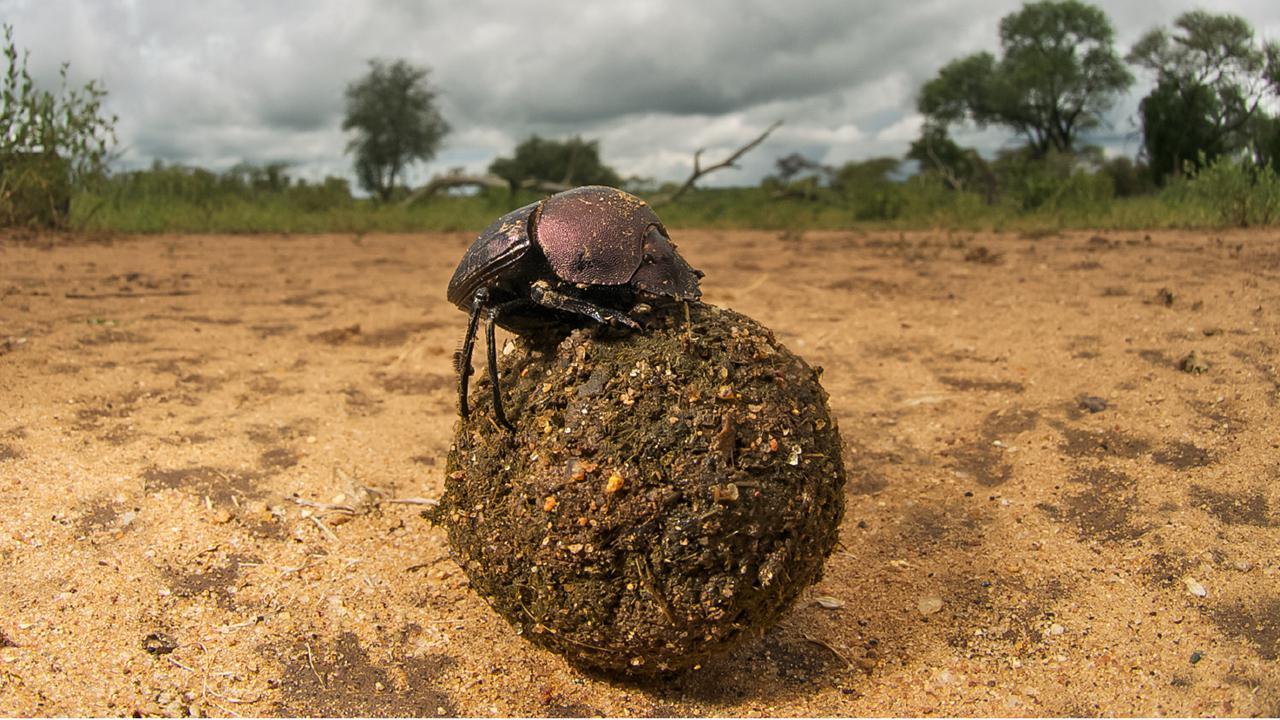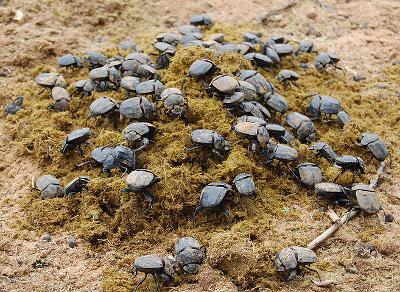The first image is the image on the left, the second image is the image on the right. Analyze the images presented: Is the assertion "There's no more than one dung beetle in the right image." valid? Answer yes or no. No. The first image is the image on the left, the second image is the image on the right. For the images displayed, is the sentence "Two beetles are crawling on the ground in the image on the left." factually correct? Answer yes or no. No. 